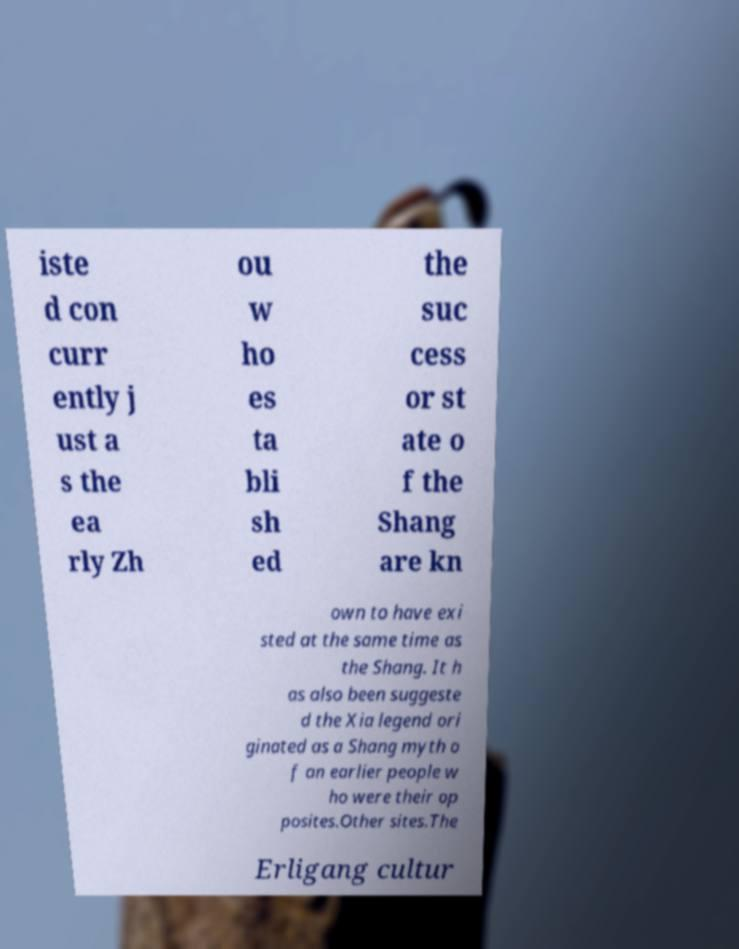Could you assist in decoding the text presented in this image and type it out clearly? iste d con curr ently j ust a s the ea rly Zh ou w ho es ta bli sh ed the suc cess or st ate o f the Shang are kn own to have exi sted at the same time as the Shang. It h as also been suggeste d the Xia legend ori ginated as a Shang myth o f an earlier people w ho were their op posites.Other sites.The Erligang cultur 